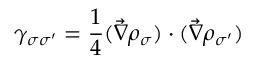Convert formula to latex. <formula><loc_0><loc_0><loc_500><loc_500>\gamma _ { \sigma \sigma ^ { \prime } } = \frac { 1 } { 4 } ( \vec { \nabla } \rho _ { \sigma } ) \cdot ( \vec { \nabla } \rho _ { \sigma ^ { \prime } } )</formula> 